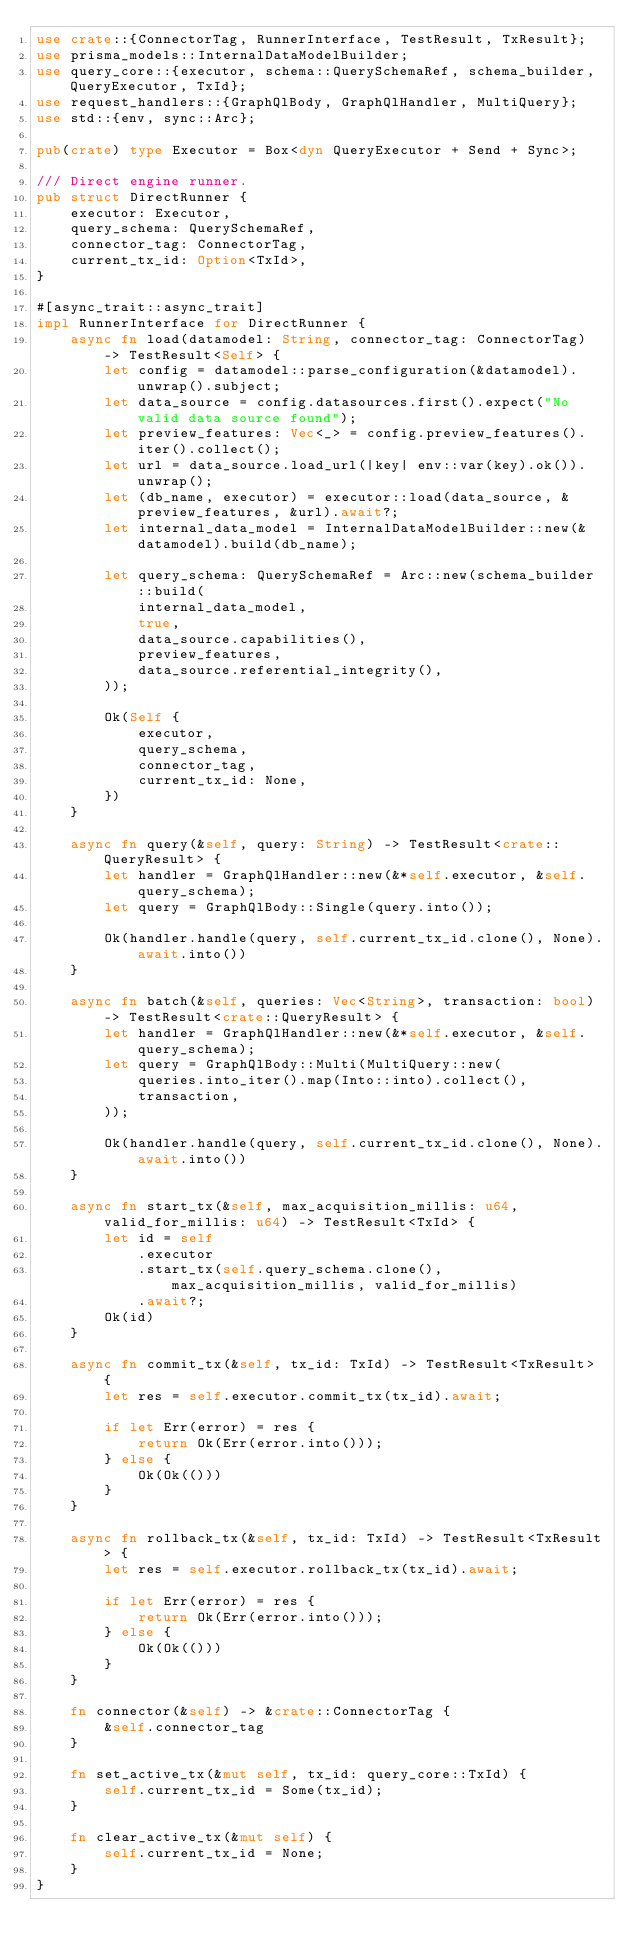Convert code to text. <code><loc_0><loc_0><loc_500><loc_500><_Rust_>use crate::{ConnectorTag, RunnerInterface, TestResult, TxResult};
use prisma_models::InternalDataModelBuilder;
use query_core::{executor, schema::QuerySchemaRef, schema_builder, QueryExecutor, TxId};
use request_handlers::{GraphQlBody, GraphQlHandler, MultiQuery};
use std::{env, sync::Arc};

pub(crate) type Executor = Box<dyn QueryExecutor + Send + Sync>;

/// Direct engine runner.
pub struct DirectRunner {
    executor: Executor,
    query_schema: QuerySchemaRef,
    connector_tag: ConnectorTag,
    current_tx_id: Option<TxId>,
}

#[async_trait::async_trait]
impl RunnerInterface for DirectRunner {
    async fn load(datamodel: String, connector_tag: ConnectorTag) -> TestResult<Self> {
        let config = datamodel::parse_configuration(&datamodel).unwrap().subject;
        let data_source = config.datasources.first().expect("No valid data source found");
        let preview_features: Vec<_> = config.preview_features().iter().collect();
        let url = data_source.load_url(|key| env::var(key).ok()).unwrap();
        let (db_name, executor) = executor::load(data_source, &preview_features, &url).await?;
        let internal_data_model = InternalDataModelBuilder::new(&datamodel).build(db_name);

        let query_schema: QuerySchemaRef = Arc::new(schema_builder::build(
            internal_data_model,
            true,
            data_source.capabilities(),
            preview_features,
            data_source.referential_integrity(),
        ));

        Ok(Self {
            executor,
            query_schema,
            connector_tag,
            current_tx_id: None,
        })
    }

    async fn query(&self, query: String) -> TestResult<crate::QueryResult> {
        let handler = GraphQlHandler::new(&*self.executor, &self.query_schema);
        let query = GraphQlBody::Single(query.into());

        Ok(handler.handle(query, self.current_tx_id.clone(), None).await.into())
    }

    async fn batch(&self, queries: Vec<String>, transaction: bool) -> TestResult<crate::QueryResult> {
        let handler = GraphQlHandler::new(&*self.executor, &self.query_schema);
        let query = GraphQlBody::Multi(MultiQuery::new(
            queries.into_iter().map(Into::into).collect(),
            transaction,
        ));

        Ok(handler.handle(query, self.current_tx_id.clone(), None).await.into())
    }

    async fn start_tx(&self, max_acquisition_millis: u64, valid_for_millis: u64) -> TestResult<TxId> {
        let id = self
            .executor
            .start_tx(self.query_schema.clone(), max_acquisition_millis, valid_for_millis)
            .await?;
        Ok(id)
    }

    async fn commit_tx(&self, tx_id: TxId) -> TestResult<TxResult> {
        let res = self.executor.commit_tx(tx_id).await;

        if let Err(error) = res {
            return Ok(Err(error.into()));
        } else {
            Ok(Ok(()))
        }
    }

    async fn rollback_tx(&self, tx_id: TxId) -> TestResult<TxResult> {
        let res = self.executor.rollback_tx(tx_id).await;

        if let Err(error) = res {
            return Ok(Err(error.into()));
        } else {
            Ok(Ok(()))
        }
    }

    fn connector(&self) -> &crate::ConnectorTag {
        &self.connector_tag
    }

    fn set_active_tx(&mut self, tx_id: query_core::TxId) {
        self.current_tx_id = Some(tx_id);
    }

    fn clear_active_tx(&mut self) {
        self.current_tx_id = None;
    }
}
</code> 